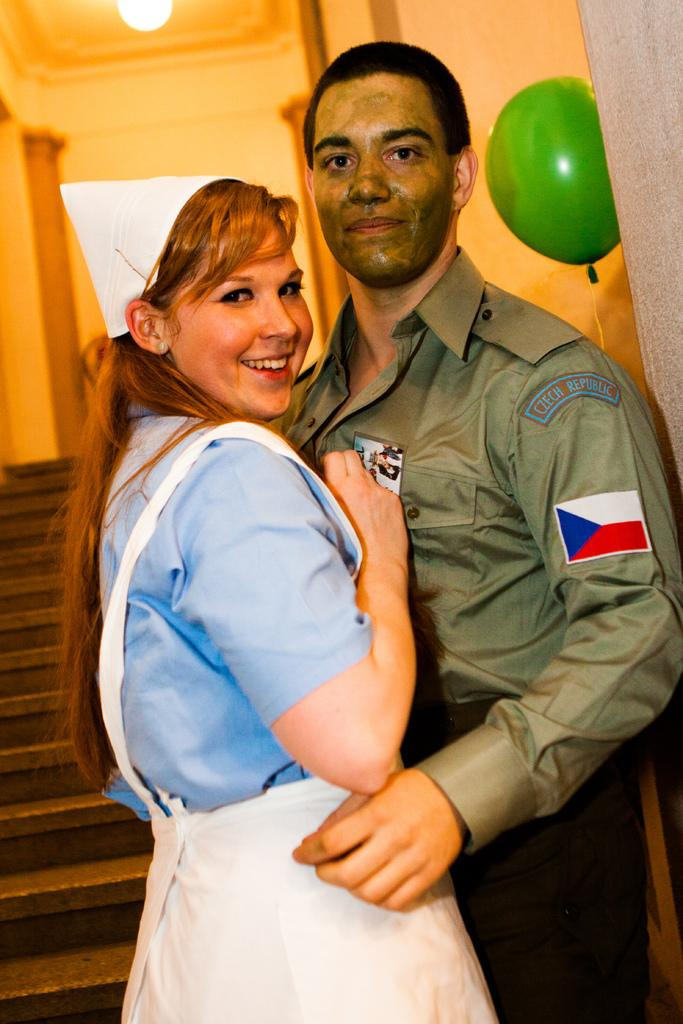How many people are in the image? There are two persons standing in the image. What is the facial expression of the persons in the image? The persons are smiling. What architectural features can be seen in the image? There are stairs and pillars visible in the image. What additional object can be seen in the image? There is a balloon in the image. What is the source of light in the image? There is a light at the top of the image. What type of structure is visible in the image? There is a wall visible in the image. What is the manager's role in the journey depicted in the image? There is no journey or manager depicted in the image; it features two smiling persons, stairs, pillars, a balloon, a light, and a wall. 